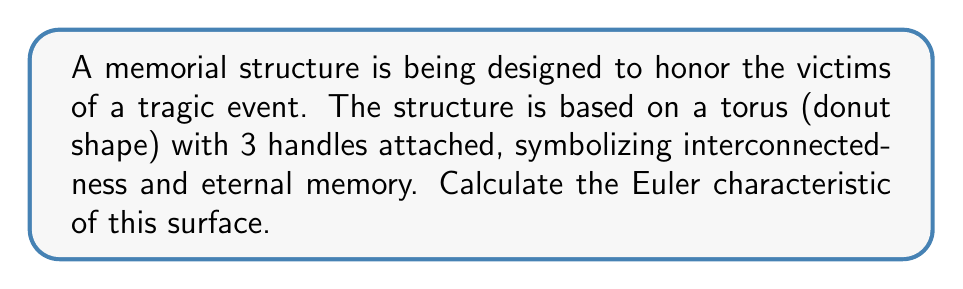Can you solve this math problem? To calculate the Euler characteristic of this surface, we'll use the formula:

$$\chi = V - E + F$$

Where:
$\chi$ is the Euler characteristic
$V$ is the number of vertices
$E$ is the number of edges
$F$ is the number of faces

For a torus with $g$ handles (also known as a genus-$g$ surface), the Euler characteristic is given by:

$$\chi = 2 - 2g$$

In this case, we have a torus (genus 1) with 3 additional handles, so the total genus is 4.

Therefore:

$$\chi = 2 - 2(4) = 2 - 8 = -6$$

We can visualize this surface as follows:

[asy]
import geometry;

size(200);
path p = circle((0,0),1);
path q = circle((0,0),0.6);
fill(p,lightgrey);
fill(q,white);
draw(p);
draw(q);
for (int i=0; i<4; i++) {
  pair c = dir(90*i);
  draw(circle(c,0.2));
}
label("Torus with 3 additional handles", (0,-1.3));
[/asy]

Each handle adds two to the genus of the surface, which decreases the Euler characteristic by 4.
Answer: $\chi = -6$ 